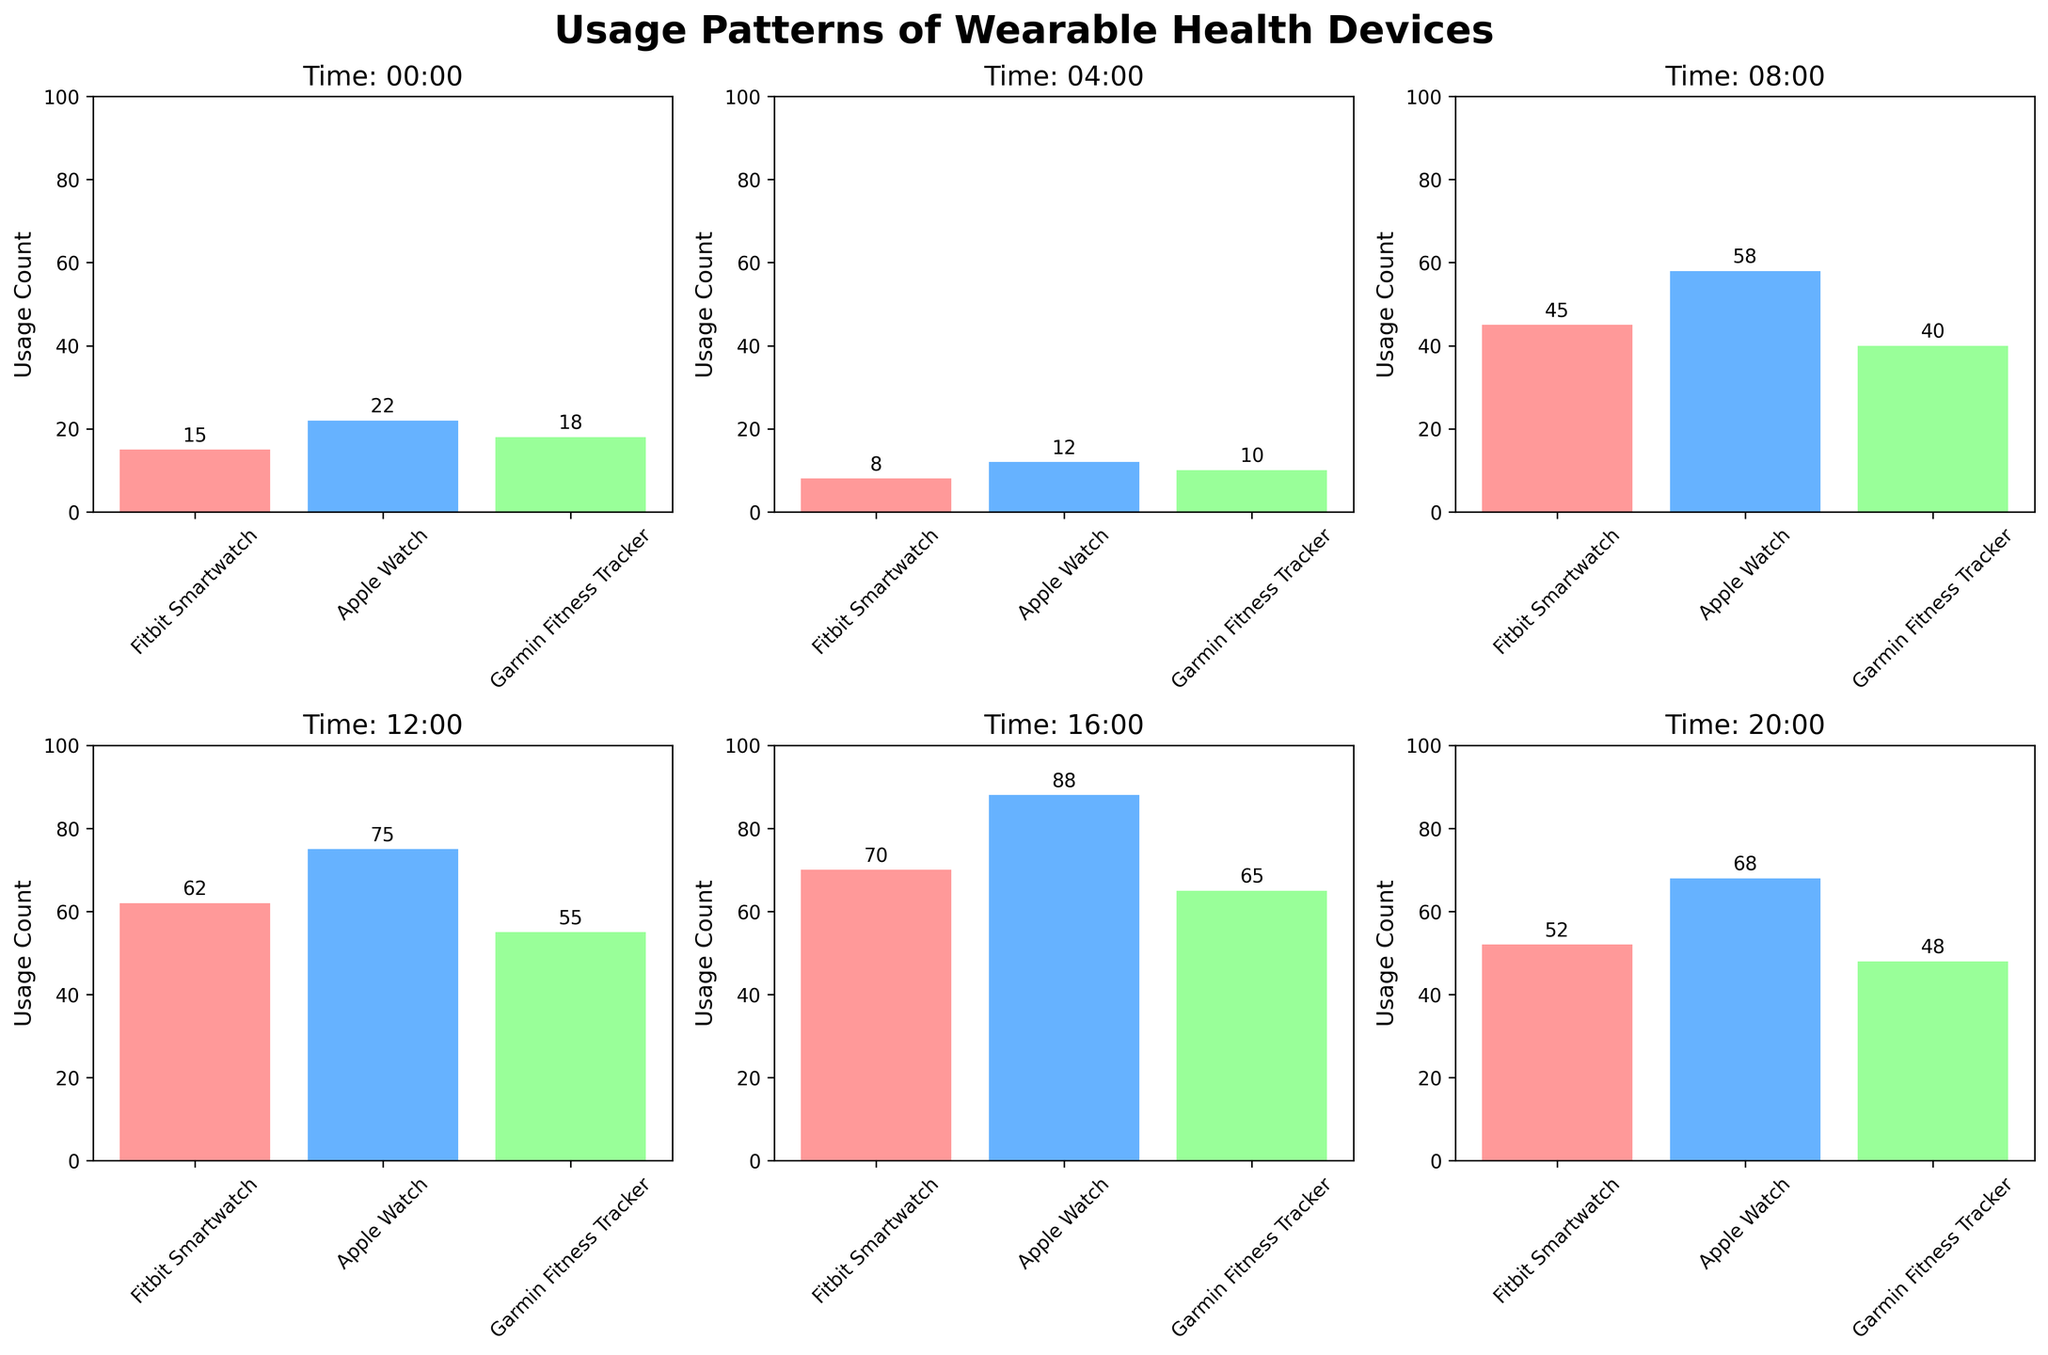What's the title of the figure? The title is found at the top of the figure and serves to provide an overview of the content being presented. It reads: "Usage Patterns of Wearable Health Devices".
Answer: Usage Patterns of Wearable Health Devices How many subplots are there in the figure? There are six distinct sections, one for each time of day being analyzed.
Answer: 6 Which time slot shows the highest usage count for the Apple Watch? By comparing the bars in the Apple Watch sections across all time slots, the 16:00 subplot has the highest bar, indicating the highest usage count.
Answer: 16:00 What's the difference in Fitbit Smartwatch usage between 08:00 and 16:00? From the figure, the usage count at 08:00 is 45 and at 16:00 is 70. Subtracting these two values gives the difference, 70 - 45.
Answer: 25 At what time of day is usage of wearable health devices lowest overall? By adding the usage counts for all devices at each time slot and comparing, 04:00 has the lowest combined total. (8 + 12 + 10 = 30)
Answer: 04:00 What's the total usage count for Garmin Fitness Tracker at 08:00 and 12:00 combined? Adding the values from the 08:00 and 12:00 plots for Garmin Fitness Tracker: 40 + 55.
Answer: 95 Which time slot shows the most balanced usage across all device types? Examining the relative heights of the bars in each subplot, 12:00 shows the most even distribution among device types: 62, 75, and 55.
Answer: 12:00 Which device type has the highest variability in usage throughout the day? By looking at the range of values for each device across the different times, the Apple Watch has the highest variability (from 12 at 04:00 to 88 at 16:00).
Answer: Apple Watch 